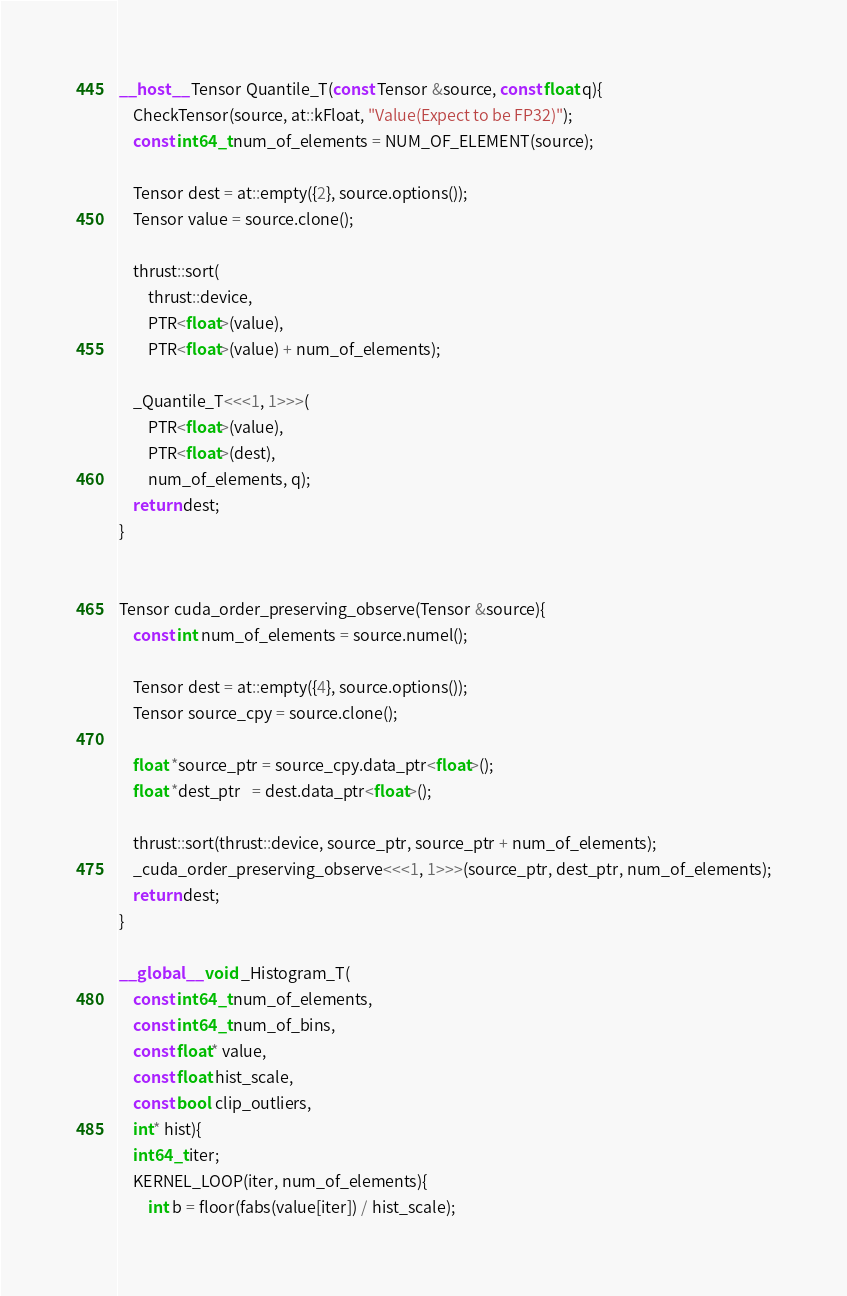Convert code to text. <code><loc_0><loc_0><loc_500><loc_500><_Cuda_>__host__ Tensor Quantile_T(const Tensor &source, const float q){
    CheckTensor(source, at::kFloat, "Value(Expect to be FP32)");
    const int64_t num_of_elements = NUM_OF_ELEMENT(source);
    
    Tensor dest = at::empty({2}, source.options());
    Tensor value = source.clone();

    thrust::sort(
        thrust::device, 
        PTR<float>(value),
        PTR<float>(value) + num_of_elements);

    _Quantile_T<<<1, 1>>>(
        PTR<float>(value), 
        PTR<float>(dest), 
        num_of_elements, q);
    return dest;
}


Tensor cuda_order_preserving_observe(Tensor &source){
    const int num_of_elements = source.numel();
    
    Tensor dest = at::empty({4}, source.options());
    Tensor source_cpy = source.clone();

    float *source_ptr = source_cpy.data_ptr<float>();
    float *dest_ptr   = dest.data_ptr<float>();

    thrust::sort(thrust::device, source_ptr, source_ptr + num_of_elements);
    _cuda_order_preserving_observe<<<1, 1>>>(source_ptr, dest_ptr, num_of_elements);
    return dest;
}

__global__ void _Histogram_T(
    const int64_t num_of_elements,
    const int64_t num_of_bins,
    const float* value,
    const float hist_scale,
    const bool clip_outliers,
    int* hist){
    int64_t iter;
    KERNEL_LOOP(iter, num_of_elements){
        int b = floor(fabs(value[iter]) / hist_scale);</code> 